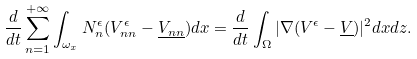<formula> <loc_0><loc_0><loc_500><loc_500>\frac { d } { d t } \sum _ { n = 1 } ^ { + \infty } \int _ { \omega _ { x } } N _ { n } ^ { \epsilon } ( V _ { n n } ^ { \epsilon } - \underline { V _ { n n } } ) d x = \frac { d } { d t } \int _ { \Omega } | \nabla ( V ^ { \epsilon } - \underline { V } ) | ^ { 2 } d x d z .</formula> 